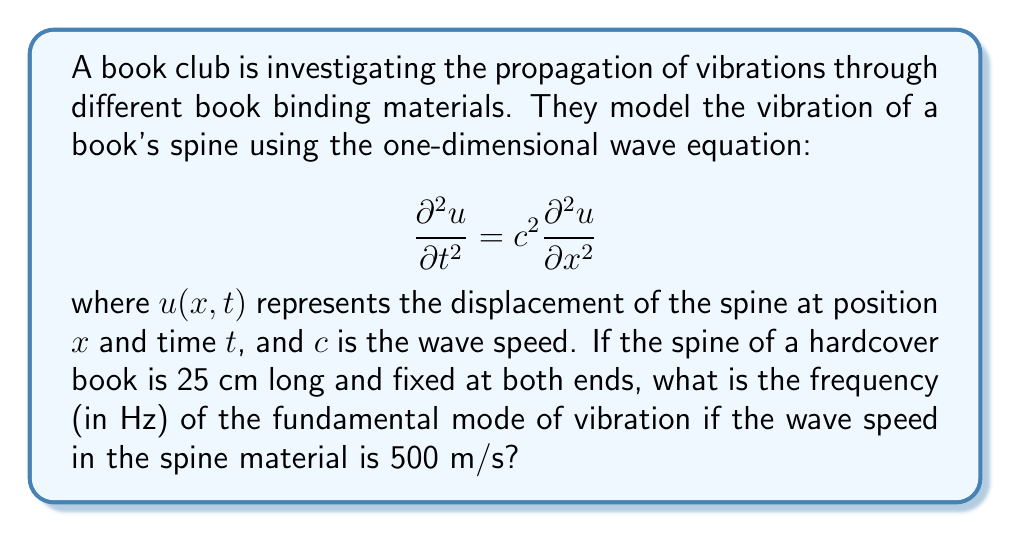Show me your answer to this math problem. Let's approach this step-by-step:

1) For a string (or in this case, a book spine) fixed at both ends, the fundamental mode of vibration corresponds to the first harmonic, where the wavelength $\lambda$ is twice the length of the string.

2) The length of the spine is 25 cm = 0.25 m. So:

   $$\lambda = 2L = 2(0.25) = 0.5 \text{ m}$$

3) We know the wave speed $c = 500 \text{ m/s}$. The relationship between wave speed, frequency, and wavelength is:

   $$c = f\lambda$$

4) Rearranging this equation to solve for frequency:

   $$f = \frac{c}{\lambda}$$

5) Substituting our known values:

   $$f = \frac{500 \text{ m/s}}{0.5 \text{ m}} = 1000 \text{ Hz}$$

Therefore, the frequency of the fundamental mode of vibration is 1000 Hz.
Answer: 1000 Hz 